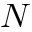Convert formula to latex. <formula><loc_0><loc_0><loc_500><loc_500>N</formula> 